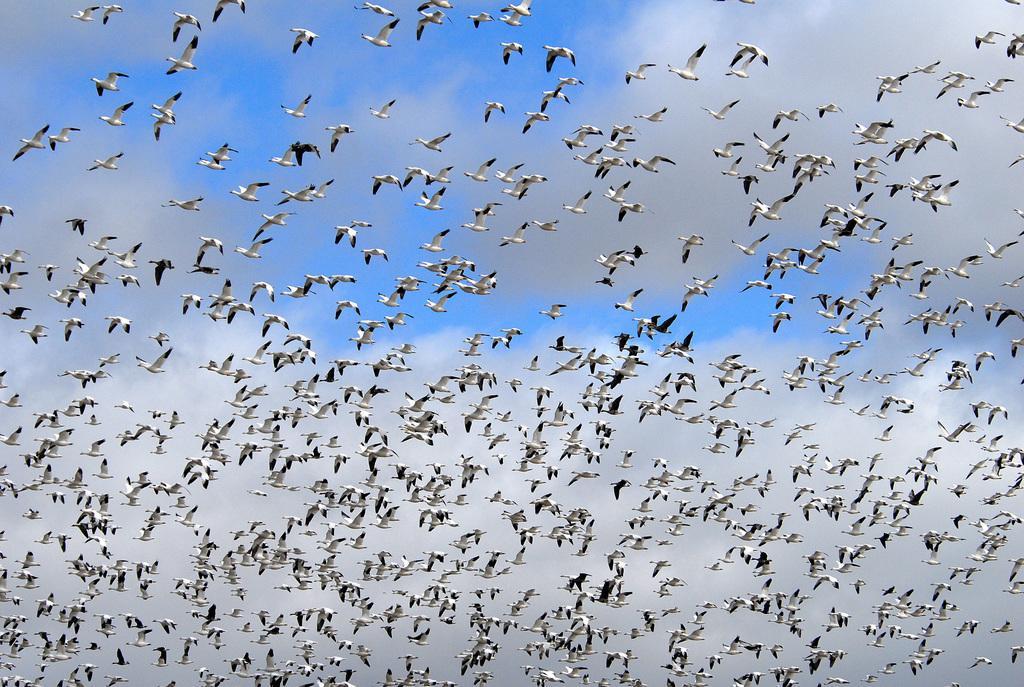Please provide a concise description of this image. In the picture I can see few birds are flying in the air and the sky is a bit cloudy. 